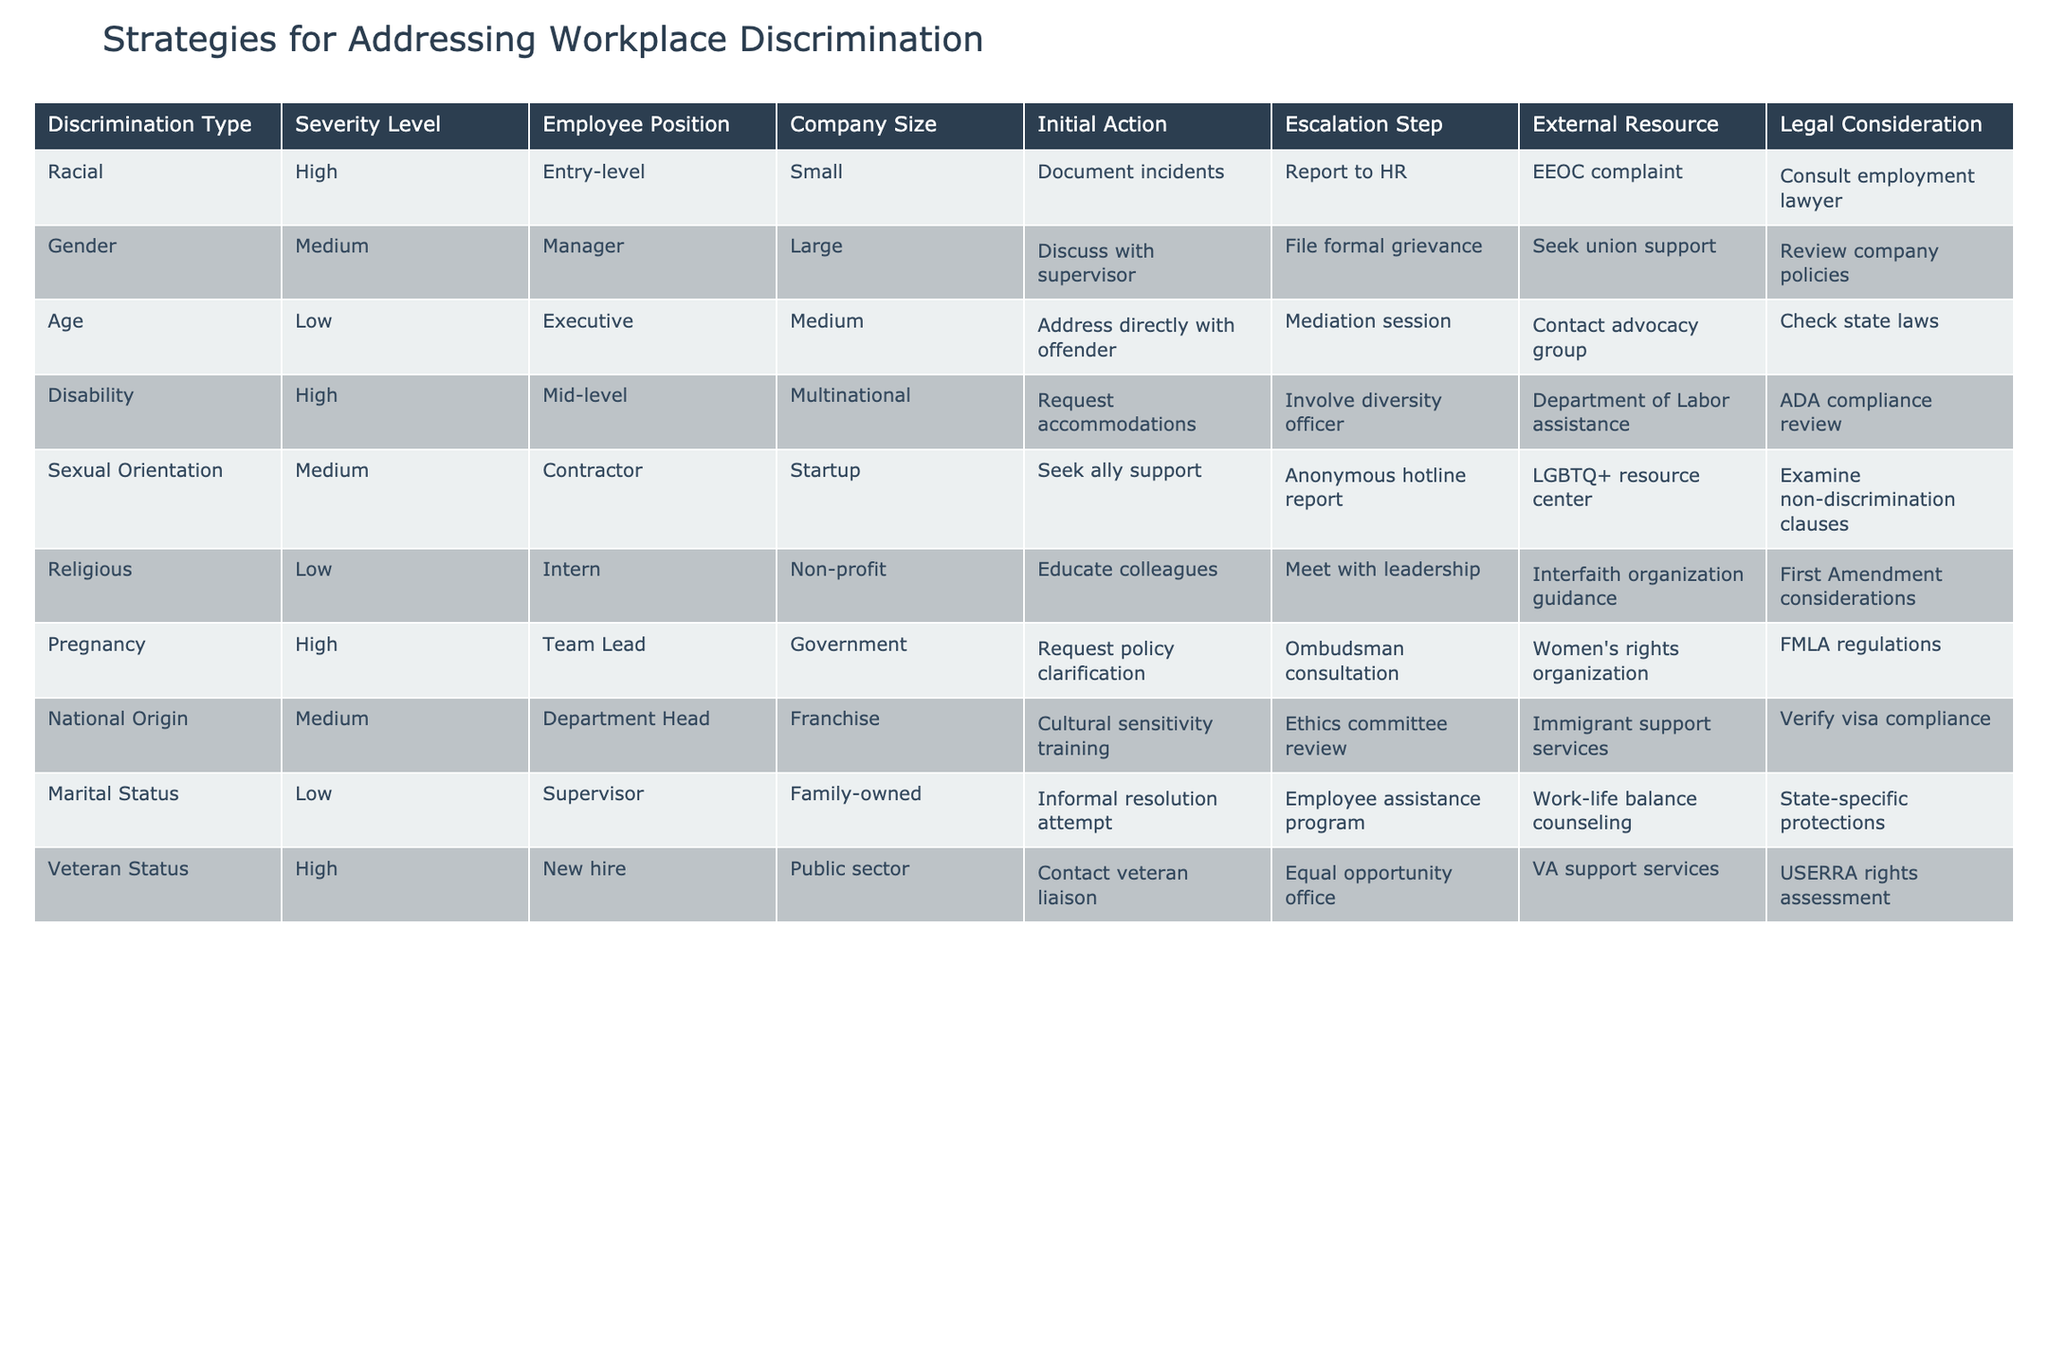What actions should be taken for high-severity racial discrimination in a small company? According to the table, for high-severity racial discrimination in a small company, the initial action is to document incidents, followed by reporting to HR. The escalation step is to file an EEOC complaint, and legal consideration involves consulting an employment lawyer.
Answer: Document incidents, report to HR, file EEOC complaint, consult employment lawyer Is there a legal consideration for addressing gender discrimination in a large company? Yes, the table indicates that the legal consideration for addressing gender discrimination in a large company includes reviewing company policies.
Answer: Yes How many different employee positions are listed for high-severity discrimination types? The table indicates three types of discrimination with high severity: racial (entry-level), disability (mid-level), and veteran status (new hire), leading to a total of three different positions.
Answer: 3 What is the escalation step for medium severity discrimination related to marital status in a family-owned company? For medium severity discrimination related to marital status in a family-owned company, the escalation step is through the Employee Assistance Program.
Answer: Employee Assistance Program If a mid-level employee experiences disability discrimination, what is the recommended initial action? The initial action for a mid-level employee experiencing disability discrimination is to request accommodations, according to the table.
Answer: Request accommodations Are there any strategies listed for contractor positions experiencing sexual orientation discrimination? Yes, for contractor positions experiencing sexual orientation discrimination, the strategies include seeking ally support as the initial action and reporting to an anonymous hotline as the escalation step.
Answer: Yes What is the common escalation step for high-severity discrimination cases? Analyzing the table, the common escalation step for high-severity cases includes involving a diversity officer for disability discrimination and contacting veteran liaison for veteran status, but not a singular common step for all. Each case has its unique approach.
Answer: No common step What is the average number of escalation steps listed across all types of discrimination? There are 9 types of discrimination with a total of 9 escalation steps listed in the table. Thus, the average number of escalation steps across discrimination types is 1 (9 steps/9 types).
Answer: 1 What is the initial action for someone facing low-severity age discrimination? For low-severity age discrimination, the initial action is to address it directly with the offender, as per the table.
Answer: Address directly with offender 